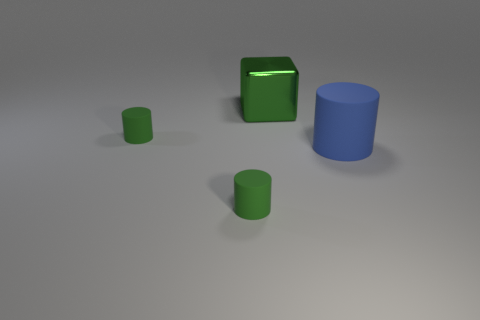Subtract all green cylinders. How many cylinders are left? 1 Subtract all green cylinders. How many cylinders are left? 1 Add 4 gray rubber objects. How many objects exist? 8 Subtract all red cylinders. How many red blocks are left? 0 Subtract 1 cylinders. How many cylinders are left? 2 Subtract all yellow cylinders. Subtract all yellow spheres. How many cylinders are left? 3 Subtract all big green shiny blocks. Subtract all brown shiny spheres. How many objects are left? 3 Add 2 blue cylinders. How many blue cylinders are left? 3 Add 1 large blue cylinders. How many large blue cylinders exist? 2 Subtract 0 yellow blocks. How many objects are left? 4 